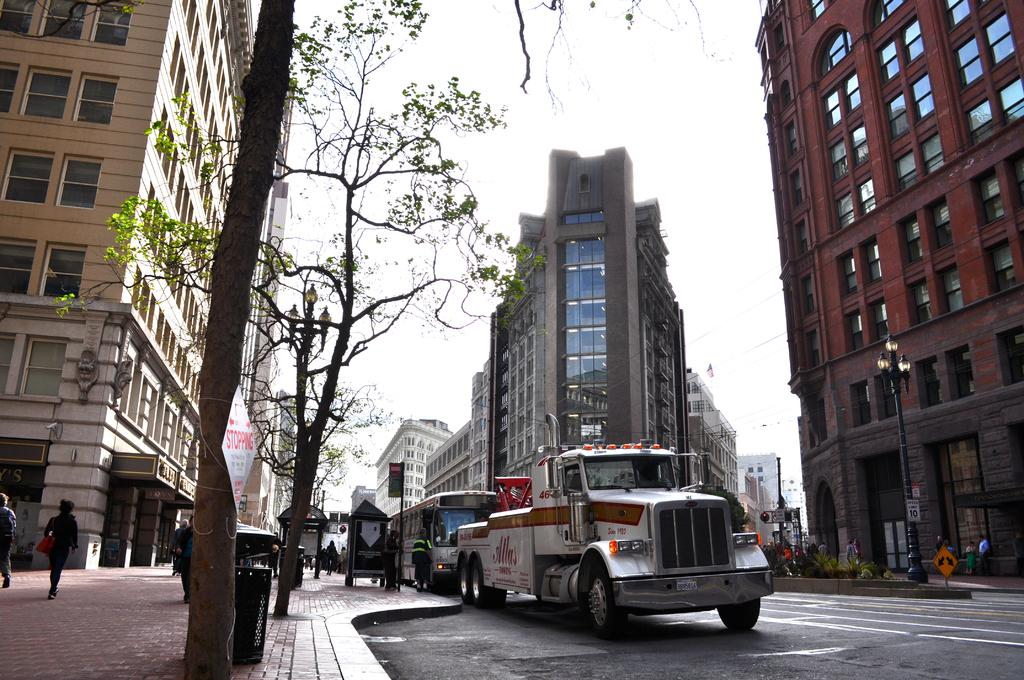What type of structures can be seen in the image? There are buildings in the image. What feature of the buildings is visible in the image? There are windows visible in the image. What type of street furniture is present in the image? Light poles are present in the image. What type of vegetation is visible in the image? Trees and plants are visible in the image. What type of waste disposal unit is present in the image? A bin is present in the image. What type of signage is visible in the image? Signboards are in the image. What type of living organisms are present in the image? People are present in the image. What type of transportation is visible in the image? Vehicles are on the road in the image. What type of canvas is visible in the image? There is no canvas present in the image. What type of range is visible in the image? There is no range present in the image. 